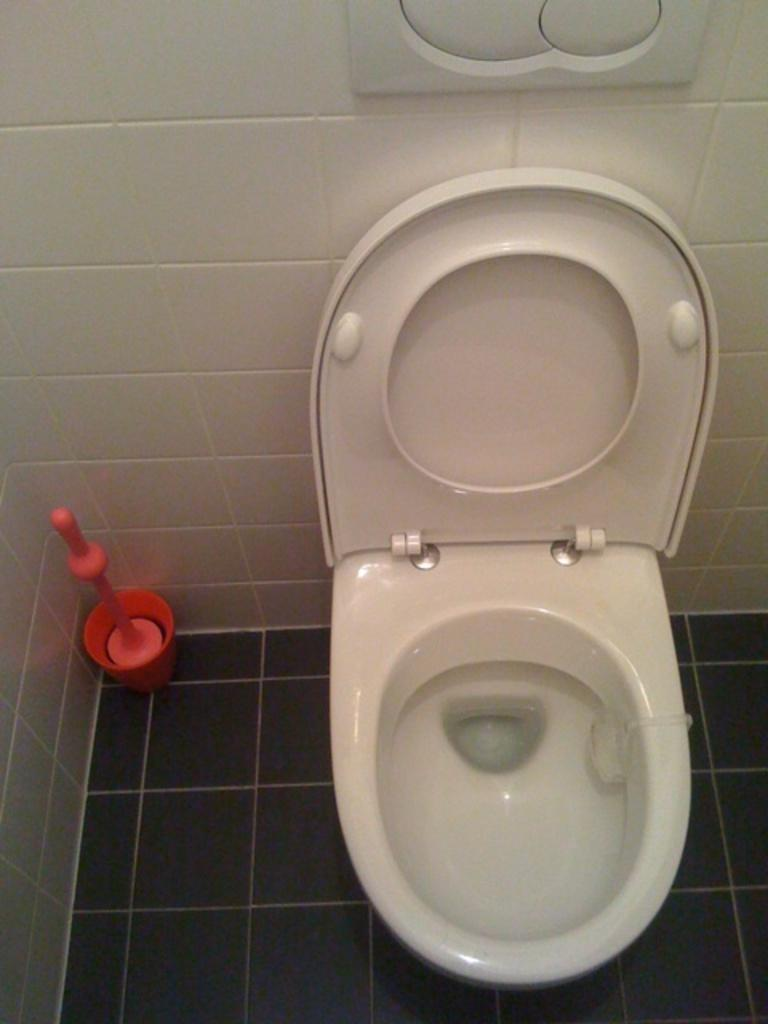What type of flooring is visible in the image? There are white color tiles in the image. What type of toilet can be seen in the image? There is a western toilet in the image. Where is the toothpaste placed in the image? There is no toothpaste present in the image. What type of furniture can be seen in the hall in the image? There is no hall or furniture present in the image. 